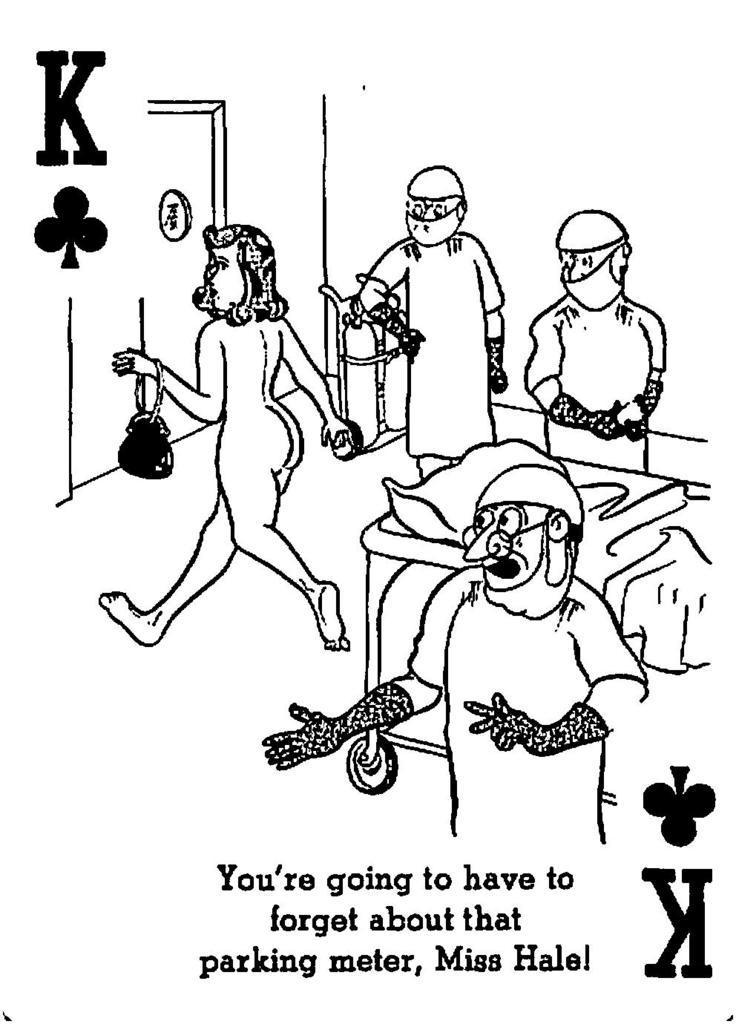Describe this image in one or two sentences. In this image we can see the picture. In the picture there are the images of women, men, stretcher, pillow and a cylinder. 